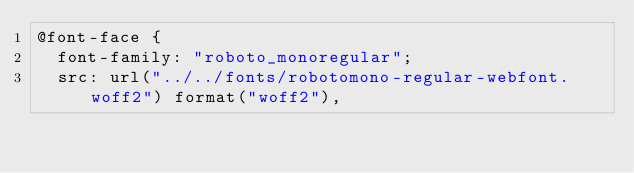Convert code to text. <code><loc_0><loc_0><loc_500><loc_500><_CSS_>@font-face {
  font-family: "roboto_monoregular";
  src: url("../../fonts/robotomono-regular-webfont.woff2") format("woff2"),</code> 